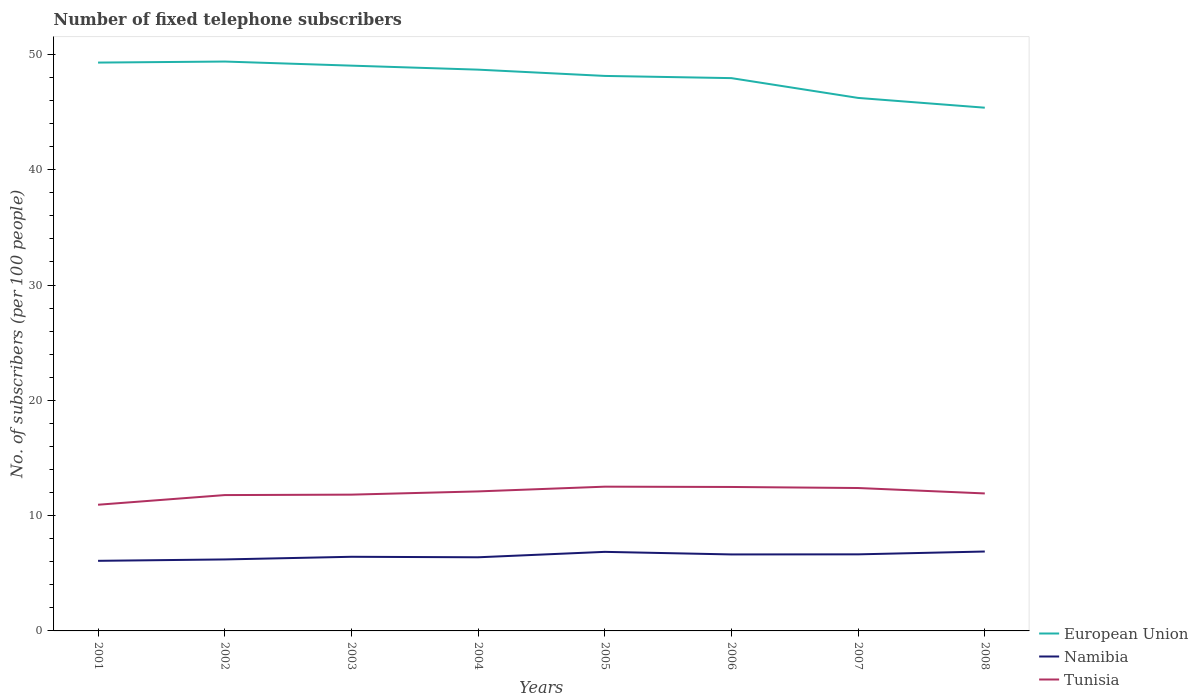Across all years, what is the maximum number of fixed telephone subscribers in Tunisia?
Your answer should be very brief. 10.94. In which year was the number of fixed telephone subscribers in Tunisia maximum?
Your answer should be very brief. 2001. What is the total number of fixed telephone subscribers in Tunisia in the graph?
Your response must be concise. 0.03. What is the difference between the highest and the second highest number of fixed telephone subscribers in Namibia?
Offer a terse response. 0.81. What is the difference between the highest and the lowest number of fixed telephone subscribers in Tunisia?
Keep it short and to the point. 4. What is the difference between two consecutive major ticks on the Y-axis?
Make the answer very short. 10. Are the values on the major ticks of Y-axis written in scientific E-notation?
Your answer should be compact. No. Does the graph contain any zero values?
Make the answer very short. No. Does the graph contain grids?
Provide a short and direct response. No. How are the legend labels stacked?
Ensure brevity in your answer.  Vertical. What is the title of the graph?
Your response must be concise. Number of fixed telephone subscribers. What is the label or title of the X-axis?
Your response must be concise. Years. What is the label or title of the Y-axis?
Your response must be concise. No. of subscribers (per 100 people). What is the No. of subscribers (per 100 people) in European Union in 2001?
Your answer should be very brief. 49.29. What is the No. of subscribers (per 100 people) in Namibia in 2001?
Ensure brevity in your answer.  6.08. What is the No. of subscribers (per 100 people) in Tunisia in 2001?
Make the answer very short. 10.94. What is the No. of subscribers (per 100 people) in European Union in 2002?
Keep it short and to the point. 49.38. What is the No. of subscribers (per 100 people) of Namibia in 2002?
Your response must be concise. 6.2. What is the No. of subscribers (per 100 people) in Tunisia in 2002?
Give a very brief answer. 11.78. What is the No. of subscribers (per 100 people) of European Union in 2003?
Give a very brief answer. 49.03. What is the No. of subscribers (per 100 people) of Namibia in 2003?
Offer a very short reply. 6.43. What is the No. of subscribers (per 100 people) of Tunisia in 2003?
Your response must be concise. 11.82. What is the No. of subscribers (per 100 people) of European Union in 2004?
Your answer should be very brief. 48.68. What is the No. of subscribers (per 100 people) of Namibia in 2004?
Your response must be concise. 6.39. What is the No. of subscribers (per 100 people) of Tunisia in 2004?
Offer a terse response. 12.1. What is the No. of subscribers (per 100 people) in European Union in 2005?
Your answer should be very brief. 48.13. What is the No. of subscribers (per 100 people) in Namibia in 2005?
Provide a succinct answer. 6.86. What is the No. of subscribers (per 100 people) in Tunisia in 2005?
Your response must be concise. 12.51. What is the No. of subscribers (per 100 people) of European Union in 2006?
Offer a terse response. 47.94. What is the No. of subscribers (per 100 people) of Namibia in 2006?
Offer a very short reply. 6.63. What is the No. of subscribers (per 100 people) in Tunisia in 2006?
Your response must be concise. 12.48. What is the No. of subscribers (per 100 people) of European Union in 2007?
Make the answer very short. 46.22. What is the No. of subscribers (per 100 people) of Namibia in 2007?
Provide a short and direct response. 6.64. What is the No. of subscribers (per 100 people) in Tunisia in 2007?
Provide a succinct answer. 12.39. What is the No. of subscribers (per 100 people) in European Union in 2008?
Your response must be concise. 45.38. What is the No. of subscribers (per 100 people) of Namibia in 2008?
Your response must be concise. 6.89. What is the No. of subscribers (per 100 people) in Tunisia in 2008?
Make the answer very short. 11.92. Across all years, what is the maximum No. of subscribers (per 100 people) in European Union?
Provide a succinct answer. 49.38. Across all years, what is the maximum No. of subscribers (per 100 people) of Namibia?
Keep it short and to the point. 6.89. Across all years, what is the maximum No. of subscribers (per 100 people) of Tunisia?
Provide a succinct answer. 12.51. Across all years, what is the minimum No. of subscribers (per 100 people) of European Union?
Offer a very short reply. 45.38. Across all years, what is the minimum No. of subscribers (per 100 people) of Namibia?
Offer a very short reply. 6.08. Across all years, what is the minimum No. of subscribers (per 100 people) of Tunisia?
Provide a succinct answer. 10.94. What is the total No. of subscribers (per 100 people) of European Union in the graph?
Provide a short and direct response. 384.05. What is the total No. of subscribers (per 100 people) of Namibia in the graph?
Provide a short and direct response. 52.11. What is the total No. of subscribers (per 100 people) in Tunisia in the graph?
Offer a terse response. 95.95. What is the difference between the No. of subscribers (per 100 people) of European Union in 2001 and that in 2002?
Your answer should be very brief. -0.09. What is the difference between the No. of subscribers (per 100 people) of Namibia in 2001 and that in 2002?
Give a very brief answer. -0.12. What is the difference between the No. of subscribers (per 100 people) in Tunisia in 2001 and that in 2002?
Ensure brevity in your answer.  -0.84. What is the difference between the No. of subscribers (per 100 people) in European Union in 2001 and that in 2003?
Give a very brief answer. 0.27. What is the difference between the No. of subscribers (per 100 people) of Namibia in 2001 and that in 2003?
Make the answer very short. -0.35. What is the difference between the No. of subscribers (per 100 people) in Tunisia in 2001 and that in 2003?
Your response must be concise. -0.88. What is the difference between the No. of subscribers (per 100 people) in European Union in 2001 and that in 2004?
Provide a succinct answer. 0.61. What is the difference between the No. of subscribers (per 100 people) in Namibia in 2001 and that in 2004?
Provide a succinct answer. -0.31. What is the difference between the No. of subscribers (per 100 people) in Tunisia in 2001 and that in 2004?
Give a very brief answer. -1.16. What is the difference between the No. of subscribers (per 100 people) in European Union in 2001 and that in 2005?
Offer a very short reply. 1.16. What is the difference between the No. of subscribers (per 100 people) of Namibia in 2001 and that in 2005?
Make the answer very short. -0.78. What is the difference between the No. of subscribers (per 100 people) in Tunisia in 2001 and that in 2005?
Your answer should be compact. -1.57. What is the difference between the No. of subscribers (per 100 people) in European Union in 2001 and that in 2006?
Your answer should be very brief. 1.35. What is the difference between the No. of subscribers (per 100 people) of Namibia in 2001 and that in 2006?
Offer a very short reply. -0.55. What is the difference between the No. of subscribers (per 100 people) in Tunisia in 2001 and that in 2006?
Ensure brevity in your answer.  -1.54. What is the difference between the No. of subscribers (per 100 people) in European Union in 2001 and that in 2007?
Your answer should be very brief. 3.07. What is the difference between the No. of subscribers (per 100 people) of Namibia in 2001 and that in 2007?
Provide a short and direct response. -0.56. What is the difference between the No. of subscribers (per 100 people) in Tunisia in 2001 and that in 2007?
Keep it short and to the point. -1.45. What is the difference between the No. of subscribers (per 100 people) of European Union in 2001 and that in 2008?
Provide a succinct answer. 3.91. What is the difference between the No. of subscribers (per 100 people) in Namibia in 2001 and that in 2008?
Ensure brevity in your answer.  -0.81. What is the difference between the No. of subscribers (per 100 people) of Tunisia in 2001 and that in 2008?
Your answer should be compact. -0.98. What is the difference between the No. of subscribers (per 100 people) of European Union in 2002 and that in 2003?
Your response must be concise. 0.36. What is the difference between the No. of subscribers (per 100 people) in Namibia in 2002 and that in 2003?
Keep it short and to the point. -0.23. What is the difference between the No. of subscribers (per 100 people) in Tunisia in 2002 and that in 2003?
Offer a very short reply. -0.04. What is the difference between the No. of subscribers (per 100 people) of European Union in 2002 and that in 2004?
Your response must be concise. 0.7. What is the difference between the No. of subscribers (per 100 people) in Namibia in 2002 and that in 2004?
Offer a terse response. -0.19. What is the difference between the No. of subscribers (per 100 people) of Tunisia in 2002 and that in 2004?
Provide a succinct answer. -0.32. What is the difference between the No. of subscribers (per 100 people) in European Union in 2002 and that in 2005?
Provide a succinct answer. 1.25. What is the difference between the No. of subscribers (per 100 people) in Namibia in 2002 and that in 2005?
Provide a succinct answer. -0.66. What is the difference between the No. of subscribers (per 100 people) in Tunisia in 2002 and that in 2005?
Provide a short and direct response. -0.73. What is the difference between the No. of subscribers (per 100 people) in European Union in 2002 and that in 2006?
Your answer should be compact. 1.44. What is the difference between the No. of subscribers (per 100 people) in Namibia in 2002 and that in 2006?
Ensure brevity in your answer.  -0.43. What is the difference between the No. of subscribers (per 100 people) in Tunisia in 2002 and that in 2006?
Keep it short and to the point. -0.7. What is the difference between the No. of subscribers (per 100 people) in European Union in 2002 and that in 2007?
Give a very brief answer. 3.16. What is the difference between the No. of subscribers (per 100 people) of Namibia in 2002 and that in 2007?
Ensure brevity in your answer.  -0.44. What is the difference between the No. of subscribers (per 100 people) in Tunisia in 2002 and that in 2007?
Offer a terse response. -0.61. What is the difference between the No. of subscribers (per 100 people) of European Union in 2002 and that in 2008?
Your answer should be compact. 4. What is the difference between the No. of subscribers (per 100 people) of Namibia in 2002 and that in 2008?
Make the answer very short. -0.69. What is the difference between the No. of subscribers (per 100 people) of Tunisia in 2002 and that in 2008?
Provide a succinct answer. -0.14. What is the difference between the No. of subscribers (per 100 people) of European Union in 2003 and that in 2004?
Offer a very short reply. 0.35. What is the difference between the No. of subscribers (per 100 people) of Namibia in 2003 and that in 2004?
Offer a very short reply. 0.04. What is the difference between the No. of subscribers (per 100 people) in Tunisia in 2003 and that in 2004?
Keep it short and to the point. -0.28. What is the difference between the No. of subscribers (per 100 people) in European Union in 2003 and that in 2005?
Provide a succinct answer. 0.89. What is the difference between the No. of subscribers (per 100 people) in Namibia in 2003 and that in 2005?
Offer a terse response. -0.43. What is the difference between the No. of subscribers (per 100 people) of Tunisia in 2003 and that in 2005?
Offer a terse response. -0.69. What is the difference between the No. of subscribers (per 100 people) in European Union in 2003 and that in 2006?
Provide a short and direct response. 1.08. What is the difference between the No. of subscribers (per 100 people) of Namibia in 2003 and that in 2006?
Make the answer very short. -0.2. What is the difference between the No. of subscribers (per 100 people) in Tunisia in 2003 and that in 2006?
Offer a terse response. -0.67. What is the difference between the No. of subscribers (per 100 people) of European Union in 2003 and that in 2007?
Give a very brief answer. 2.8. What is the difference between the No. of subscribers (per 100 people) of Namibia in 2003 and that in 2007?
Your answer should be very brief. -0.21. What is the difference between the No. of subscribers (per 100 people) of Tunisia in 2003 and that in 2007?
Make the answer very short. -0.57. What is the difference between the No. of subscribers (per 100 people) in European Union in 2003 and that in 2008?
Ensure brevity in your answer.  3.65. What is the difference between the No. of subscribers (per 100 people) in Namibia in 2003 and that in 2008?
Provide a succinct answer. -0.46. What is the difference between the No. of subscribers (per 100 people) of Tunisia in 2003 and that in 2008?
Offer a very short reply. -0.1. What is the difference between the No. of subscribers (per 100 people) of European Union in 2004 and that in 2005?
Provide a short and direct response. 0.54. What is the difference between the No. of subscribers (per 100 people) of Namibia in 2004 and that in 2005?
Make the answer very short. -0.47. What is the difference between the No. of subscribers (per 100 people) of Tunisia in 2004 and that in 2005?
Make the answer very short. -0.41. What is the difference between the No. of subscribers (per 100 people) in European Union in 2004 and that in 2006?
Your response must be concise. 0.74. What is the difference between the No. of subscribers (per 100 people) of Namibia in 2004 and that in 2006?
Your response must be concise. -0.25. What is the difference between the No. of subscribers (per 100 people) of Tunisia in 2004 and that in 2006?
Provide a short and direct response. -0.39. What is the difference between the No. of subscribers (per 100 people) in European Union in 2004 and that in 2007?
Provide a short and direct response. 2.45. What is the difference between the No. of subscribers (per 100 people) of Namibia in 2004 and that in 2007?
Ensure brevity in your answer.  -0.25. What is the difference between the No. of subscribers (per 100 people) in Tunisia in 2004 and that in 2007?
Offer a very short reply. -0.29. What is the difference between the No. of subscribers (per 100 people) in European Union in 2004 and that in 2008?
Your answer should be very brief. 3.3. What is the difference between the No. of subscribers (per 100 people) in Namibia in 2004 and that in 2008?
Your answer should be very brief. -0.5. What is the difference between the No. of subscribers (per 100 people) of Tunisia in 2004 and that in 2008?
Provide a short and direct response. 0.17. What is the difference between the No. of subscribers (per 100 people) of European Union in 2005 and that in 2006?
Make the answer very short. 0.19. What is the difference between the No. of subscribers (per 100 people) in Namibia in 2005 and that in 2006?
Provide a succinct answer. 0.22. What is the difference between the No. of subscribers (per 100 people) in Tunisia in 2005 and that in 2006?
Your answer should be compact. 0.03. What is the difference between the No. of subscribers (per 100 people) of European Union in 2005 and that in 2007?
Give a very brief answer. 1.91. What is the difference between the No. of subscribers (per 100 people) of Namibia in 2005 and that in 2007?
Ensure brevity in your answer.  0.22. What is the difference between the No. of subscribers (per 100 people) in Tunisia in 2005 and that in 2007?
Your response must be concise. 0.12. What is the difference between the No. of subscribers (per 100 people) of European Union in 2005 and that in 2008?
Keep it short and to the point. 2.76. What is the difference between the No. of subscribers (per 100 people) of Namibia in 2005 and that in 2008?
Your response must be concise. -0.03. What is the difference between the No. of subscribers (per 100 people) in Tunisia in 2005 and that in 2008?
Your answer should be compact. 0.59. What is the difference between the No. of subscribers (per 100 people) of European Union in 2006 and that in 2007?
Provide a short and direct response. 1.72. What is the difference between the No. of subscribers (per 100 people) of Namibia in 2006 and that in 2007?
Your response must be concise. -0.01. What is the difference between the No. of subscribers (per 100 people) in Tunisia in 2006 and that in 2007?
Your response must be concise. 0.09. What is the difference between the No. of subscribers (per 100 people) in European Union in 2006 and that in 2008?
Offer a terse response. 2.56. What is the difference between the No. of subscribers (per 100 people) in Namibia in 2006 and that in 2008?
Your response must be concise. -0.25. What is the difference between the No. of subscribers (per 100 people) of Tunisia in 2006 and that in 2008?
Make the answer very short. 0.56. What is the difference between the No. of subscribers (per 100 people) of European Union in 2007 and that in 2008?
Provide a succinct answer. 0.85. What is the difference between the No. of subscribers (per 100 people) of Namibia in 2007 and that in 2008?
Your response must be concise. -0.25. What is the difference between the No. of subscribers (per 100 people) in Tunisia in 2007 and that in 2008?
Your answer should be compact. 0.47. What is the difference between the No. of subscribers (per 100 people) of European Union in 2001 and the No. of subscribers (per 100 people) of Namibia in 2002?
Offer a terse response. 43.09. What is the difference between the No. of subscribers (per 100 people) of European Union in 2001 and the No. of subscribers (per 100 people) of Tunisia in 2002?
Give a very brief answer. 37.51. What is the difference between the No. of subscribers (per 100 people) of Namibia in 2001 and the No. of subscribers (per 100 people) of Tunisia in 2002?
Offer a terse response. -5.7. What is the difference between the No. of subscribers (per 100 people) of European Union in 2001 and the No. of subscribers (per 100 people) of Namibia in 2003?
Your response must be concise. 42.86. What is the difference between the No. of subscribers (per 100 people) in European Union in 2001 and the No. of subscribers (per 100 people) in Tunisia in 2003?
Make the answer very short. 37.47. What is the difference between the No. of subscribers (per 100 people) in Namibia in 2001 and the No. of subscribers (per 100 people) in Tunisia in 2003?
Keep it short and to the point. -5.74. What is the difference between the No. of subscribers (per 100 people) of European Union in 2001 and the No. of subscribers (per 100 people) of Namibia in 2004?
Offer a terse response. 42.9. What is the difference between the No. of subscribers (per 100 people) of European Union in 2001 and the No. of subscribers (per 100 people) of Tunisia in 2004?
Ensure brevity in your answer.  37.19. What is the difference between the No. of subscribers (per 100 people) of Namibia in 2001 and the No. of subscribers (per 100 people) of Tunisia in 2004?
Offer a very short reply. -6.02. What is the difference between the No. of subscribers (per 100 people) in European Union in 2001 and the No. of subscribers (per 100 people) in Namibia in 2005?
Provide a succinct answer. 42.43. What is the difference between the No. of subscribers (per 100 people) of European Union in 2001 and the No. of subscribers (per 100 people) of Tunisia in 2005?
Your answer should be compact. 36.78. What is the difference between the No. of subscribers (per 100 people) of Namibia in 2001 and the No. of subscribers (per 100 people) of Tunisia in 2005?
Ensure brevity in your answer.  -6.43. What is the difference between the No. of subscribers (per 100 people) of European Union in 2001 and the No. of subscribers (per 100 people) of Namibia in 2006?
Provide a short and direct response. 42.66. What is the difference between the No. of subscribers (per 100 people) in European Union in 2001 and the No. of subscribers (per 100 people) in Tunisia in 2006?
Keep it short and to the point. 36.81. What is the difference between the No. of subscribers (per 100 people) in Namibia in 2001 and the No. of subscribers (per 100 people) in Tunisia in 2006?
Your response must be concise. -6.41. What is the difference between the No. of subscribers (per 100 people) of European Union in 2001 and the No. of subscribers (per 100 people) of Namibia in 2007?
Give a very brief answer. 42.65. What is the difference between the No. of subscribers (per 100 people) in European Union in 2001 and the No. of subscribers (per 100 people) in Tunisia in 2007?
Your answer should be compact. 36.9. What is the difference between the No. of subscribers (per 100 people) of Namibia in 2001 and the No. of subscribers (per 100 people) of Tunisia in 2007?
Your response must be concise. -6.32. What is the difference between the No. of subscribers (per 100 people) in European Union in 2001 and the No. of subscribers (per 100 people) in Namibia in 2008?
Give a very brief answer. 42.4. What is the difference between the No. of subscribers (per 100 people) in European Union in 2001 and the No. of subscribers (per 100 people) in Tunisia in 2008?
Make the answer very short. 37.37. What is the difference between the No. of subscribers (per 100 people) of Namibia in 2001 and the No. of subscribers (per 100 people) of Tunisia in 2008?
Ensure brevity in your answer.  -5.85. What is the difference between the No. of subscribers (per 100 people) in European Union in 2002 and the No. of subscribers (per 100 people) in Namibia in 2003?
Provide a succinct answer. 42.95. What is the difference between the No. of subscribers (per 100 people) of European Union in 2002 and the No. of subscribers (per 100 people) of Tunisia in 2003?
Your answer should be very brief. 37.56. What is the difference between the No. of subscribers (per 100 people) of Namibia in 2002 and the No. of subscribers (per 100 people) of Tunisia in 2003?
Offer a terse response. -5.62. What is the difference between the No. of subscribers (per 100 people) of European Union in 2002 and the No. of subscribers (per 100 people) of Namibia in 2004?
Your response must be concise. 42.99. What is the difference between the No. of subscribers (per 100 people) of European Union in 2002 and the No. of subscribers (per 100 people) of Tunisia in 2004?
Provide a succinct answer. 37.28. What is the difference between the No. of subscribers (per 100 people) of Namibia in 2002 and the No. of subscribers (per 100 people) of Tunisia in 2004?
Keep it short and to the point. -5.9. What is the difference between the No. of subscribers (per 100 people) in European Union in 2002 and the No. of subscribers (per 100 people) in Namibia in 2005?
Make the answer very short. 42.52. What is the difference between the No. of subscribers (per 100 people) of European Union in 2002 and the No. of subscribers (per 100 people) of Tunisia in 2005?
Make the answer very short. 36.87. What is the difference between the No. of subscribers (per 100 people) of Namibia in 2002 and the No. of subscribers (per 100 people) of Tunisia in 2005?
Your answer should be very brief. -6.31. What is the difference between the No. of subscribers (per 100 people) of European Union in 2002 and the No. of subscribers (per 100 people) of Namibia in 2006?
Your answer should be compact. 42.75. What is the difference between the No. of subscribers (per 100 people) in European Union in 2002 and the No. of subscribers (per 100 people) in Tunisia in 2006?
Your answer should be very brief. 36.9. What is the difference between the No. of subscribers (per 100 people) in Namibia in 2002 and the No. of subscribers (per 100 people) in Tunisia in 2006?
Keep it short and to the point. -6.28. What is the difference between the No. of subscribers (per 100 people) in European Union in 2002 and the No. of subscribers (per 100 people) in Namibia in 2007?
Your answer should be compact. 42.74. What is the difference between the No. of subscribers (per 100 people) of European Union in 2002 and the No. of subscribers (per 100 people) of Tunisia in 2007?
Keep it short and to the point. 36.99. What is the difference between the No. of subscribers (per 100 people) in Namibia in 2002 and the No. of subscribers (per 100 people) in Tunisia in 2007?
Your answer should be very brief. -6.19. What is the difference between the No. of subscribers (per 100 people) of European Union in 2002 and the No. of subscribers (per 100 people) of Namibia in 2008?
Provide a short and direct response. 42.49. What is the difference between the No. of subscribers (per 100 people) of European Union in 2002 and the No. of subscribers (per 100 people) of Tunisia in 2008?
Your answer should be compact. 37.46. What is the difference between the No. of subscribers (per 100 people) in Namibia in 2002 and the No. of subscribers (per 100 people) in Tunisia in 2008?
Make the answer very short. -5.72. What is the difference between the No. of subscribers (per 100 people) of European Union in 2003 and the No. of subscribers (per 100 people) of Namibia in 2004?
Your response must be concise. 42.64. What is the difference between the No. of subscribers (per 100 people) of European Union in 2003 and the No. of subscribers (per 100 people) of Tunisia in 2004?
Provide a short and direct response. 36.93. What is the difference between the No. of subscribers (per 100 people) of Namibia in 2003 and the No. of subscribers (per 100 people) of Tunisia in 2004?
Your answer should be compact. -5.67. What is the difference between the No. of subscribers (per 100 people) in European Union in 2003 and the No. of subscribers (per 100 people) in Namibia in 2005?
Your answer should be compact. 42.17. What is the difference between the No. of subscribers (per 100 people) in European Union in 2003 and the No. of subscribers (per 100 people) in Tunisia in 2005?
Offer a very short reply. 36.51. What is the difference between the No. of subscribers (per 100 people) of Namibia in 2003 and the No. of subscribers (per 100 people) of Tunisia in 2005?
Provide a succinct answer. -6.08. What is the difference between the No. of subscribers (per 100 people) of European Union in 2003 and the No. of subscribers (per 100 people) of Namibia in 2006?
Your answer should be very brief. 42.39. What is the difference between the No. of subscribers (per 100 people) in European Union in 2003 and the No. of subscribers (per 100 people) in Tunisia in 2006?
Make the answer very short. 36.54. What is the difference between the No. of subscribers (per 100 people) of Namibia in 2003 and the No. of subscribers (per 100 people) of Tunisia in 2006?
Your answer should be very brief. -6.06. What is the difference between the No. of subscribers (per 100 people) in European Union in 2003 and the No. of subscribers (per 100 people) in Namibia in 2007?
Keep it short and to the point. 42.38. What is the difference between the No. of subscribers (per 100 people) of European Union in 2003 and the No. of subscribers (per 100 people) of Tunisia in 2007?
Make the answer very short. 36.63. What is the difference between the No. of subscribers (per 100 people) in Namibia in 2003 and the No. of subscribers (per 100 people) in Tunisia in 2007?
Your answer should be very brief. -5.96. What is the difference between the No. of subscribers (per 100 people) in European Union in 2003 and the No. of subscribers (per 100 people) in Namibia in 2008?
Ensure brevity in your answer.  42.14. What is the difference between the No. of subscribers (per 100 people) in European Union in 2003 and the No. of subscribers (per 100 people) in Tunisia in 2008?
Your answer should be very brief. 37.1. What is the difference between the No. of subscribers (per 100 people) of Namibia in 2003 and the No. of subscribers (per 100 people) of Tunisia in 2008?
Your answer should be compact. -5.49. What is the difference between the No. of subscribers (per 100 people) in European Union in 2004 and the No. of subscribers (per 100 people) in Namibia in 2005?
Your response must be concise. 41.82. What is the difference between the No. of subscribers (per 100 people) in European Union in 2004 and the No. of subscribers (per 100 people) in Tunisia in 2005?
Your answer should be very brief. 36.17. What is the difference between the No. of subscribers (per 100 people) of Namibia in 2004 and the No. of subscribers (per 100 people) of Tunisia in 2005?
Offer a terse response. -6.12. What is the difference between the No. of subscribers (per 100 people) in European Union in 2004 and the No. of subscribers (per 100 people) in Namibia in 2006?
Provide a short and direct response. 42.04. What is the difference between the No. of subscribers (per 100 people) of European Union in 2004 and the No. of subscribers (per 100 people) of Tunisia in 2006?
Provide a short and direct response. 36.19. What is the difference between the No. of subscribers (per 100 people) in Namibia in 2004 and the No. of subscribers (per 100 people) in Tunisia in 2006?
Ensure brevity in your answer.  -6.1. What is the difference between the No. of subscribers (per 100 people) of European Union in 2004 and the No. of subscribers (per 100 people) of Namibia in 2007?
Offer a very short reply. 42.04. What is the difference between the No. of subscribers (per 100 people) in European Union in 2004 and the No. of subscribers (per 100 people) in Tunisia in 2007?
Give a very brief answer. 36.28. What is the difference between the No. of subscribers (per 100 people) of Namibia in 2004 and the No. of subscribers (per 100 people) of Tunisia in 2007?
Your response must be concise. -6.01. What is the difference between the No. of subscribers (per 100 people) of European Union in 2004 and the No. of subscribers (per 100 people) of Namibia in 2008?
Give a very brief answer. 41.79. What is the difference between the No. of subscribers (per 100 people) of European Union in 2004 and the No. of subscribers (per 100 people) of Tunisia in 2008?
Offer a very short reply. 36.75. What is the difference between the No. of subscribers (per 100 people) of Namibia in 2004 and the No. of subscribers (per 100 people) of Tunisia in 2008?
Ensure brevity in your answer.  -5.54. What is the difference between the No. of subscribers (per 100 people) in European Union in 2005 and the No. of subscribers (per 100 people) in Namibia in 2006?
Keep it short and to the point. 41.5. What is the difference between the No. of subscribers (per 100 people) of European Union in 2005 and the No. of subscribers (per 100 people) of Tunisia in 2006?
Ensure brevity in your answer.  35.65. What is the difference between the No. of subscribers (per 100 people) in Namibia in 2005 and the No. of subscribers (per 100 people) in Tunisia in 2006?
Provide a short and direct response. -5.63. What is the difference between the No. of subscribers (per 100 people) in European Union in 2005 and the No. of subscribers (per 100 people) in Namibia in 2007?
Give a very brief answer. 41.49. What is the difference between the No. of subscribers (per 100 people) in European Union in 2005 and the No. of subscribers (per 100 people) in Tunisia in 2007?
Provide a short and direct response. 35.74. What is the difference between the No. of subscribers (per 100 people) of Namibia in 2005 and the No. of subscribers (per 100 people) of Tunisia in 2007?
Offer a terse response. -5.54. What is the difference between the No. of subscribers (per 100 people) of European Union in 2005 and the No. of subscribers (per 100 people) of Namibia in 2008?
Your response must be concise. 41.25. What is the difference between the No. of subscribers (per 100 people) in European Union in 2005 and the No. of subscribers (per 100 people) in Tunisia in 2008?
Offer a terse response. 36.21. What is the difference between the No. of subscribers (per 100 people) in Namibia in 2005 and the No. of subscribers (per 100 people) in Tunisia in 2008?
Your response must be concise. -5.07. What is the difference between the No. of subscribers (per 100 people) of European Union in 2006 and the No. of subscribers (per 100 people) of Namibia in 2007?
Ensure brevity in your answer.  41.3. What is the difference between the No. of subscribers (per 100 people) of European Union in 2006 and the No. of subscribers (per 100 people) of Tunisia in 2007?
Ensure brevity in your answer.  35.55. What is the difference between the No. of subscribers (per 100 people) in Namibia in 2006 and the No. of subscribers (per 100 people) in Tunisia in 2007?
Your response must be concise. -5.76. What is the difference between the No. of subscribers (per 100 people) in European Union in 2006 and the No. of subscribers (per 100 people) in Namibia in 2008?
Offer a terse response. 41.05. What is the difference between the No. of subscribers (per 100 people) in European Union in 2006 and the No. of subscribers (per 100 people) in Tunisia in 2008?
Keep it short and to the point. 36.02. What is the difference between the No. of subscribers (per 100 people) in Namibia in 2006 and the No. of subscribers (per 100 people) in Tunisia in 2008?
Your response must be concise. -5.29. What is the difference between the No. of subscribers (per 100 people) in European Union in 2007 and the No. of subscribers (per 100 people) in Namibia in 2008?
Offer a terse response. 39.34. What is the difference between the No. of subscribers (per 100 people) in European Union in 2007 and the No. of subscribers (per 100 people) in Tunisia in 2008?
Provide a succinct answer. 34.3. What is the difference between the No. of subscribers (per 100 people) of Namibia in 2007 and the No. of subscribers (per 100 people) of Tunisia in 2008?
Give a very brief answer. -5.28. What is the average No. of subscribers (per 100 people) in European Union per year?
Provide a succinct answer. 48.01. What is the average No. of subscribers (per 100 people) in Namibia per year?
Make the answer very short. 6.51. What is the average No. of subscribers (per 100 people) in Tunisia per year?
Your answer should be compact. 11.99. In the year 2001, what is the difference between the No. of subscribers (per 100 people) in European Union and No. of subscribers (per 100 people) in Namibia?
Your answer should be very brief. 43.21. In the year 2001, what is the difference between the No. of subscribers (per 100 people) of European Union and No. of subscribers (per 100 people) of Tunisia?
Make the answer very short. 38.35. In the year 2001, what is the difference between the No. of subscribers (per 100 people) in Namibia and No. of subscribers (per 100 people) in Tunisia?
Make the answer very short. -4.86. In the year 2002, what is the difference between the No. of subscribers (per 100 people) of European Union and No. of subscribers (per 100 people) of Namibia?
Provide a short and direct response. 43.18. In the year 2002, what is the difference between the No. of subscribers (per 100 people) in European Union and No. of subscribers (per 100 people) in Tunisia?
Provide a short and direct response. 37.6. In the year 2002, what is the difference between the No. of subscribers (per 100 people) in Namibia and No. of subscribers (per 100 people) in Tunisia?
Make the answer very short. -5.58. In the year 2003, what is the difference between the No. of subscribers (per 100 people) of European Union and No. of subscribers (per 100 people) of Namibia?
Your answer should be compact. 42.6. In the year 2003, what is the difference between the No. of subscribers (per 100 people) of European Union and No. of subscribers (per 100 people) of Tunisia?
Your answer should be very brief. 37.21. In the year 2003, what is the difference between the No. of subscribers (per 100 people) of Namibia and No. of subscribers (per 100 people) of Tunisia?
Your response must be concise. -5.39. In the year 2004, what is the difference between the No. of subscribers (per 100 people) of European Union and No. of subscribers (per 100 people) of Namibia?
Ensure brevity in your answer.  42.29. In the year 2004, what is the difference between the No. of subscribers (per 100 people) in European Union and No. of subscribers (per 100 people) in Tunisia?
Provide a succinct answer. 36.58. In the year 2004, what is the difference between the No. of subscribers (per 100 people) in Namibia and No. of subscribers (per 100 people) in Tunisia?
Ensure brevity in your answer.  -5.71. In the year 2005, what is the difference between the No. of subscribers (per 100 people) in European Union and No. of subscribers (per 100 people) in Namibia?
Ensure brevity in your answer.  41.28. In the year 2005, what is the difference between the No. of subscribers (per 100 people) in European Union and No. of subscribers (per 100 people) in Tunisia?
Keep it short and to the point. 35.62. In the year 2005, what is the difference between the No. of subscribers (per 100 people) of Namibia and No. of subscribers (per 100 people) of Tunisia?
Provide a short and direct response. -5.65. In the year 2006, what is the difference between the No. of subscribers (per 100 people) in European Union and No. of subscribers (per 100 people) in Namibia?
Offer a terse response. 41.31. In the year 2006, what is the difference between the No. of subscribers (per 100 people) in European Union and No. of subscribers (per 100 people) in Tunisia?
Ensure brevity in your answer.  35.46. In the year 2006, what is the difference between the No. of subscribers (per 100 people) of Namibia and No. of subscribers (per 100 people) of Tunisia?
Offer a terse response. -5.85. In the year 2007, what is the difference between the No. of subscribers (per 100 people) of European Union and No. of subscribers (per 100 people) of Namibia?
Your answer should be very brief. 39.58. In the year 2007, what is the difference between the No. of subscribers (per 100 people) of European Union and No. of subscribers (per 100 people) of Tunisia?
Make the answer very short. 33.83. In the year 2007, what is the difference between the No. of subscribers (per 100 people) in Namibia and No. of subscribers (per 100 people) in Tunisia?
Offer a very short reply. -5.75. In the year 2008, what is the difference between the No. of subscribers (per 100 people) of European Union and No. of subscribers (per 100 people) of Namibia?
Offer a very short reply. 38.49. In the year 2008, what is the difference between the No. of subscribers (per 100 people) in European Union and No. of subscribers (per 100 people) in Tunisia?
Provide a succinct answer. 33.45. In the year 2008, what is the difference between the No. of subscribers (per 100 people) of Namibia and No. of subscribers (per 100 people) of Tunisia?
Give a very brief answer. -5.04. What is the ratio of the No. of subscribers (per 100 people) in European Union in 2001 to that in 2002?
Your answer should be compact. 1. What is the ratio of the No. of subscribers (per 100 people) of Namibia in 2001 to that in 2002?
Your answer should be compact. 0.98. What is the ratio of the No. of subscribers (per 100 people) in Tunisia in 2001 to that in 2002?
Provide a succinct answer. 0.93. What is the ratio of the No. of subscribers (per 100 people) of European Union in 2001 to that in 2003?
Ensure brevity in your answer.  1.01. What is the ratio of the No. of subscribers (per 100 people) in Namibia in 2001 to that in 2003?
Give a very brief answer. 0.95. What is the ratio of the No. of subscribers (per 100 people) in Tunisia in 2001 to that in 2003?
Make the answer very short. 0.93. What is the ratio of the No. of subscribers (per 100 people) in European Union in 2001 to that in 2004?
Your answer should be very brief. 1.01. What is the ratio of the No. of subscribers (per 100 people) in Namibia in 2001 to that in 2004?
Your response must be concise. 0.95. What is the ratio of the No. of subscribers (per 100 people) of Tunisia in 2001 to that in 2004?
Offer a terse response. 0.9. What is the ratio of the No. of subscribers (per 100 people) in Namibia in 2001 to that in 2005?
Offer a terse response. 0.89. What is the ratio of the No. of subscribers (per 100 people) of Tunisia in 2001 to that in 2005?
Keep it short and to the point. 0.87. What is the ratio of the No. of subscribers (per 100 people) of European Union in 2001 to that in 2006?
Ensure brevity in your answer.  1.03. What is the ratio of the No. of subscribers (per 100 people) in Namibia in 2001 to that in 2006?
Your answer should be very brief. 0.92. What is the ratio of the No. of subscribers (per 100 people) in Tunisia in 2001 to that in 2006?
Ensure brevity in your answer.  0.88. What is the ratio of the No. of subscribers (per 100 people) of European Union in 2001 to that in 2007?
Ensure brevity in your answer.  1.07. What is the ratio of the No. of subscribers (per 100 people) of Namibia in 2001 to that in 2007?
Provide a short and direct response. 0.92. What is the ratio of the No. of subscribers (per 100 people) in Tunisia in 2001 to that in 2007?
Your answer should be compact. 0.88. What is the ratio of the No. of subscribers (per 100 people) of European Union in 2001 to that in 2008?
Ensure brevity in your answer.  1.09. What is the ratio of the No. of subscribers (per 100 people) of Namibia in 2001 to that in 2008?
Provide a short and direct response. 0.88. What is the ratio of the No. of subscribers (per 100 people) in Tunisia in 2001 to that in 2008?
Provide a succinct answer. 0.92. What is the ratio of the No. of subscribers (per 100 people) of Namibia in 2002 to that in 2003?
Offer a very short reply. 0.96. What is the ratio of the No. of subscribers (per 100 people) in Tunisia in 2002 to that in 2003?
Your response must be concise. 1. What is the ratio of the No. of subscribers (per 100 people) of European Union in 2002 to that in 2004?
Your answer should be compact. 1.01. What is the ratio of the No. of subscribers (per 100 people) of Namibia in 2002 to that in 2004?
Provide a succinct answer. 0.97. What is the ratio of the No. of subscribers (per 100 people) of Tunisia in 2002 to that in 2004?
Offer a very short reply. 0.97. What is the ratio of the No. of subscribers (per 100 people) in European Union in 2002 to that in 2005?
Your answer should be compact. 1.03. What is the ratio of the No. of subscribers (per 100 people) of Namibia in 2002 to that in 2005?
Provide a succinct answer. 0.9. What is the ratio of the No. of subscribers (per 100 people) in Tunisia in 2002 to that in 2005?
Offer a very short reply. 0.94. What is the ratio of the No. of subscribers (per 100 people) of Namibia in 2002 to that in 2006?
Keep it short and to the point. 0.93. What is the ratio of the No. of subscribers (per 100 people) of Tunisia in 2002 to that in 2006?
Give a very brief answer. 0.94. What is the ratio of the No. of subscribers (per 100 people) in European Union in 2002 to that in 2007?
Make the answer very short. 1.07. What is the ratio of the No. of subscribers (per 100 people) in Namibia in 2002 to that in 2007?
Provide a short and direct response. 0.93. What is the ratio of the No. of subscribers (per 100 people) in Tunisia in 2002 to that in 2007?
Provide a short and direct response. 0.95. What is the ratio of the No. of subscribers (per 100 people) of European Union in 2002 to that in 2008?
Keep it short and to the point. 1.09. What is the ratio of the No. of subscribers (per 100 people) in Namibia in 2002 to that in 2008?
Your response must be concise. 0.9. What is the ratio of the No. of subscribers (per 100 people) of Tunisia in 2002 to that in 2008?
Offer a terse response. 0.99. What is the ratio of the No. of subscribers (per 100 people) of Namibia in 2003 to that in 2004?
Provide a short and direct response. 1.01. What is the ratio of the No. of subscribers (per 100 people) of Tunisia in 2003 to that in 2004?
Offer a very short reply. 0.98. What is the ratio of the No. of subscribers (per 100 people) of European Union in 2003 to that in 2005?
Give a very brief answer. 1.02. What is the ratio of the No. of subscribers (per 100 people) of Namibia in 2003 to that in 2005?
Your answer should be very brief. 0.94. What is the ratio of the No. of subscribers (per 100 people) in Tunisia in 2003 to that in 2005?
Provide a succinct answer. 0.94. What is the ratio of the No. of subscribers (per 100 people) in European Union in 2003 to that in 2006?
Offer a very short reply. 1.02. What is the ratio of the No. of subscribers (per 100 people) in Namibia in 2003 to that in 2006?
Your response must be concise. 0.97. What is the ratio of the No. of subscribers (per 100 people) of Tunisia in 2003 to that in 2006?
Keep it short and to the point. 0.95. What is the ratio of the No. of subscribers (per 100 people) of European Union in 2003 to that in 2007?
Offer a terse response. 1.06. What is the ratio of the No. of subscribers (per 100 people) of Namibia in 2003 to that in 2007?
Provide a short and direct response. 0.97. What is the ratio of the No. of subscribers (per 100 people) in Tunisia in 2003 to that in 2007?
Offer a very short reply. 0.95. What is the ratio of the No. of subscribers (per 100 people) in European Union in 2003 to that in 2008?
Your answer should be compact. 1.08. What is the ratio of the No. of subscribers (per 100 people) in Namibia in 2003 to that in 2008?
Your answer should be compact. 0.93. What is the ratio of the No. of subscribers (per 100 people) of Tunisia in 2003 to that in 2008?
Keep it short and to the point. 0.99. What is the ratio of the No. of subscribers (per 100 people) of European Union in 2004 to that in 2005?
Your response must be concise. 1.01. What is the ratio of the No. of subscribers (per 100 people) of Namibia in 2004 to that in 2005?
Your response must be concise. 0.93. What is the ratio of the No. of subscribers (per 100 people) of Tunisia in 2004 to that in 2005?
Provide a short and direct response. 0.97. What is the ratio of the No. of subscribers (per 100 people) of European Union in 2004 to that in 2006?
Your response must be concise. 1.02. What is the ratio of the No. of subscribers (per 100 people) of Namibia in 2004 to that in 2006?
Your answer should be very brief. 0.96. What is the ratio of the No. of subscribers (per 100 people) of Tunisia in 2004 to that in 2006?
Offer a very short reply. 0.97. What is the ratio of the No. of subscribers (per 100 people) of European Union in 2004 to that in 2007?
Your answer should be very brief. 1.05. What is the ratio of the No. of subscribers (per 100 people) in Namibia in 2004 to that in 2007?
Provide a short and direct response. 0.96. What is the ratio of the No. of subscribers (per 100 people) of Tunisia in 2004 to that in 2007?
Ensure brevity in your answer.  0.98. What is the ratio of the No. of subscribers (per 100 people) of European Union in 2004 to that in 2008?
Your answer should be compact. 1.07. What is the ratio of the No. of subscribers (per 100 people) of Namibia in 2004 to that in 2008?
Provide a succinct answer. 0.93. What is the ratio of the No. of subscribers (per 100 people) in Tunisia in 2004 to that in 2008?
Keep it short and to the point. 1.01. What is the ratio of the No. of subscribers (per 100 people) in European Union in 2005 to that in 2006?
Offer a terse response. 1. What is the ratio of the No. of subscribers (per 100 people) in Namibia in 2005 to that in 2006?
Provide a succinct answer. 1.03. What is the ratio of the No. of subscribers (per 100 people) in Tunisia in 2005 to that in 2006?
Provide a short and direct response. 1. What is the ratio of the No. of subscribers (per 100 people) of European Union in 2005 to that in 2007?
Provide a succinct answer. 1.04. What is the ratio of the No. of subscribers (per 100 people) of Namibia in 2005 to that in 2007?
Offer a terse response. 1.03. What is the ratio of the No. of subscribers (per 100 people) in Tunisia in 2005 to that in 2007?
Keep it short and to the point. 1.01. What is the ratio of the No. of subscribers (per 100 people) in European Union in 2005 to that in 2008?
Provide a short and direct response. 1.06. What is the ratio of the No. of subscribers (per 100 people) of Namibia in 2005 to that in 2008?
Your answer should be compact. 1. What is the ratio of the No. of subscribers (per 100 people) in Tunisia in 2005 to that in 2008?
Keep it short and to the point. 1.05. What is the ratio of the No. of subscribers (per 100 people) in European Union in 2006 to that in 2007?
Provide a short and direct response. 1.04. What is the ratio of the No. of subscribers (per 100 people) in Namibia in 2006 to that in 2007?
Provide a succinct answer. 1. What is the ratio of the No. of subscribers (per 100 people) in Tunisia in 2006 to that in 2007?
Offer a terse response. 1.01. What is the ratio of the No. of subscribers (per 100 people) of European Union in 2006 to that in 2008?
Provide a short and direct response. 1.06. What is the ratio of the No. of subscribers (per 100 people) of Namibia in 2006 to that in 2008?
Provide a short and direct response. 0.96. What is the ratio of the No. of subscribers (per 100 people) in Tunisia in 2006 to that in 2008?
Your answer should be very brief. 1.05. What is the ratio of the No. of subscribers (per 100 people) in European Union in 2007 to that in 2008?
Your response must be concise. 1.02. What is the ratio of the No. of subscribers (per 100 people) in Tunisia in 2007 to that in 2008?
Offer a very short reply. 1.04. What is the difference between the highest and the second highest No. of subscribers (per 100 people) in European Union?
Offer a terse response. 0.09. What is the difference between the highest and the second highest No. of subscribers (per 100 people) in Namibia?
Your answer should be very brief. 0.03. What is the difference between the highest and the second highest No. of subscribers (per 100 people) in Tunisia?
Offer a terse response. 0.03. What is the difference between the highest and the lowest No. of subscribers (per 100 people) in European Union?
Offer a very short reply. 4. What is the difference between the highest and the lowest No. of subscribers (per 100 people) of Namibia?
Give a very brief answer. 0.81. What is the difference between the highest and the lowest No. of subscribers (per 100 people) in Tunisia?
Provide a short and direct response. 1.57. 